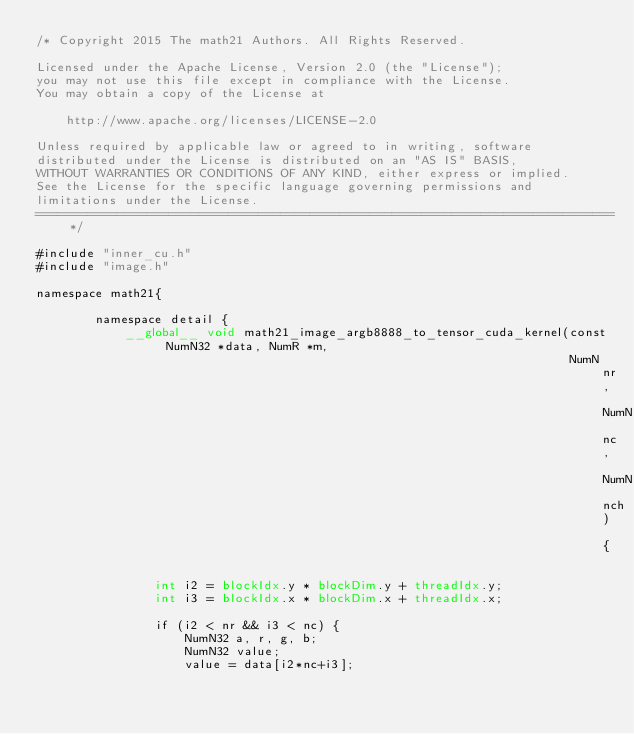Convert code to text. <code><loc_0><loc_0><loc_500><loc_500><_Cuda_>/* Copyright 2015 The math21 Authors. All Rights Reserved.

Licensed under the Apache License, Version 2.0 (the "License");
you may not use this file except in compliance with the License.
You may obtain a copy of the License at

    http://www.apache.org/licenses/LICENSE-2.0

Unless required by applicable law or agreed to in writing, software
distributed under the License is distributed on an "AS IS" BASIS,
WITHOUT WARRANTIES OR CONDITIONS OF ANY KIND, either express or implied.
See the License for the specific language governing permissions and
limitations under the License.
==============================================================================*/

#include "inner_cu.h"
#include "image.h"

namespace math21{

        namespace detail {
            __global__ void math21_image_argb8888_to_tensor_cuda_kernel(const NumN32 *data, NumR *m,
                                                                        NumN nr, NumN nc, NumN nch) {

                int i2 = blockIdx.y * blockDim.y + threadIdx.y;
                int i3 = blockIdx.x * blockDim.x + threadIdx.x;

                if (i2 < nr && i3 < nc) {
                    NumN32 a, r, g, b;
                    NumN32 value;
                    value = data[i2*nc+i3];
</code> 